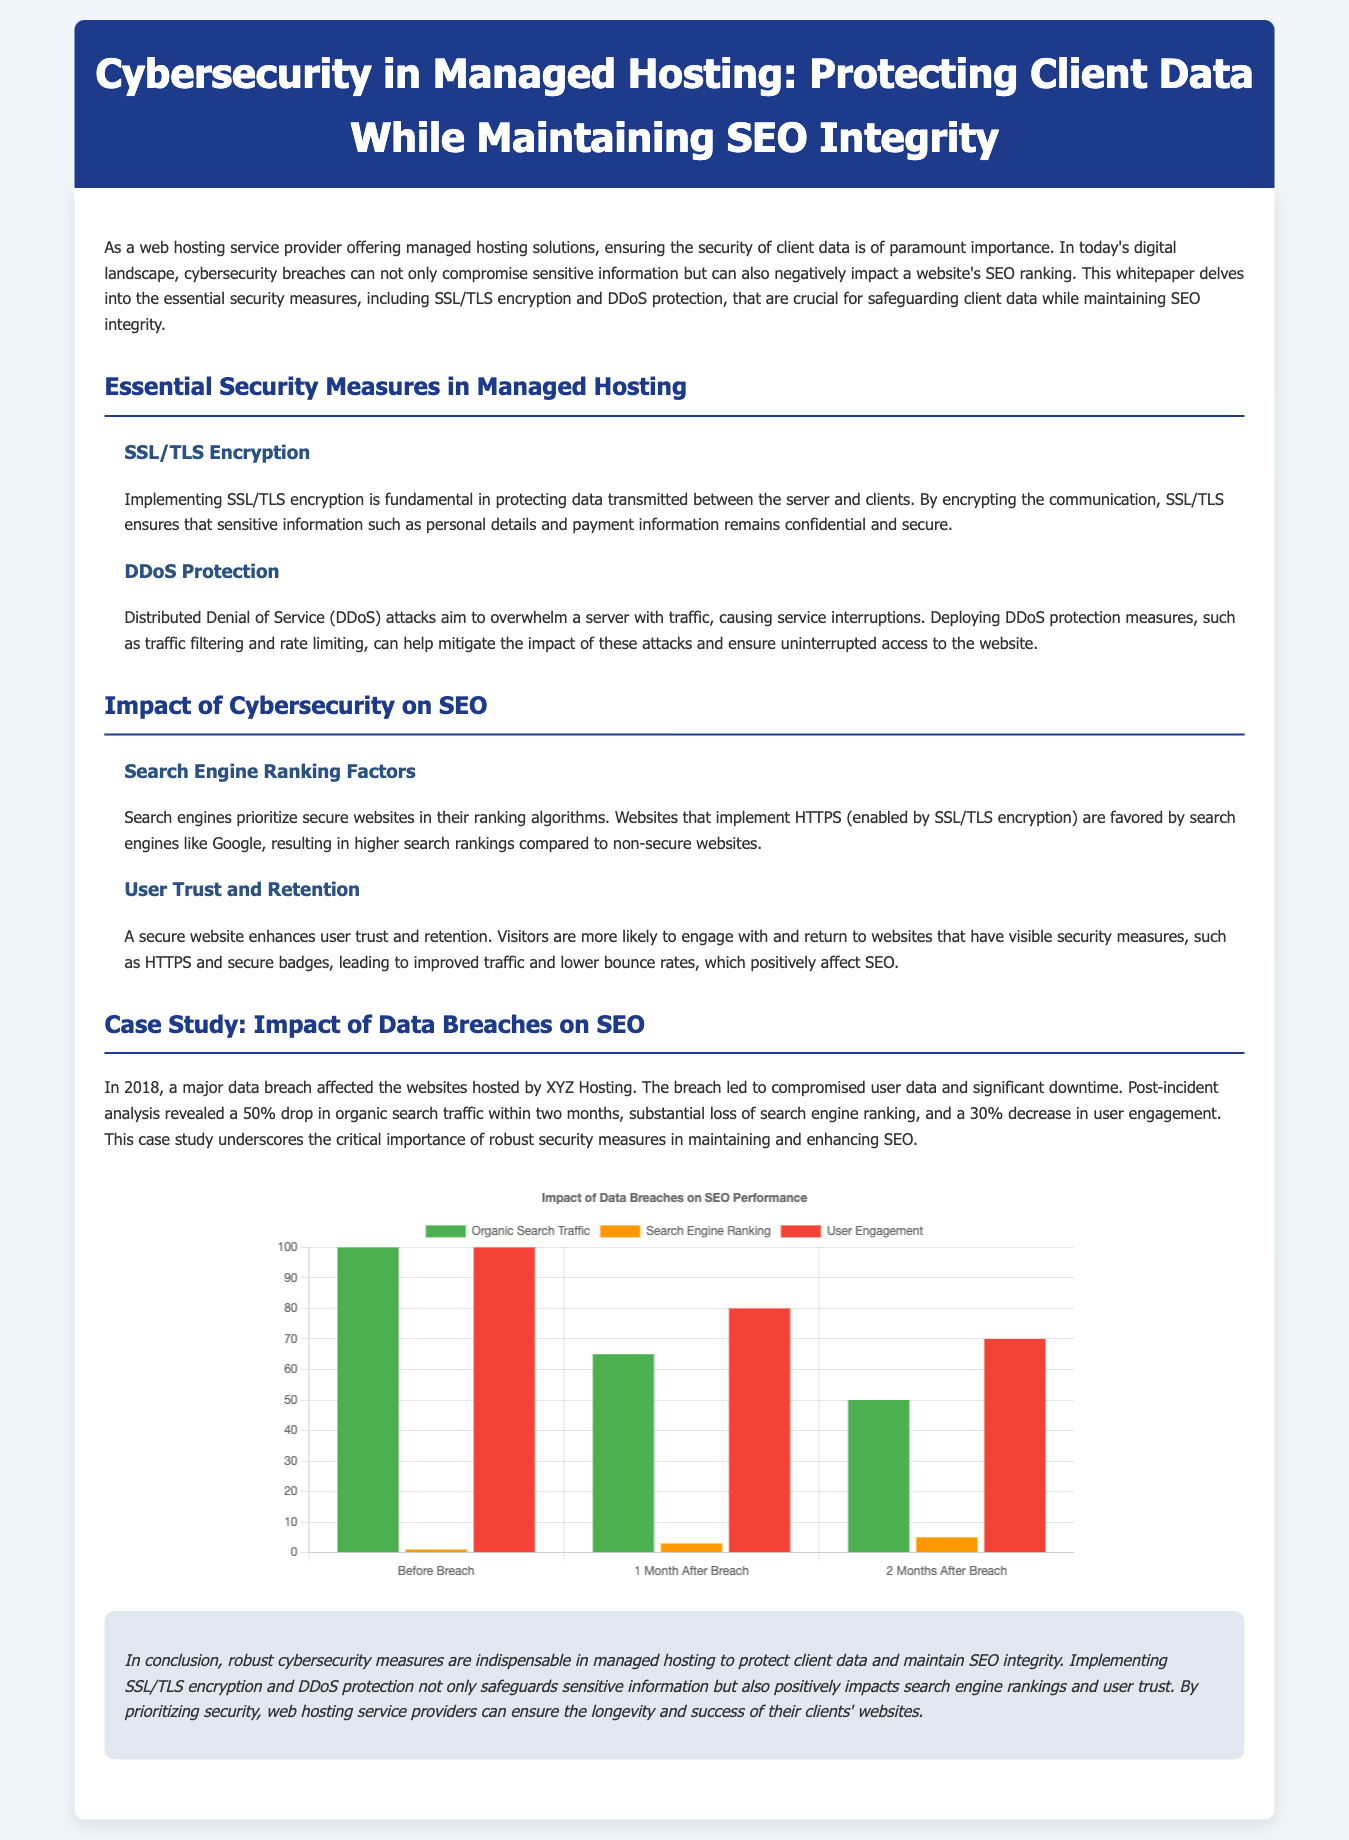what does SSL stand for? The document mentions SSL as an essential part of cybersecurity measures, specifically referring to the importance of encryption.
Answer: Secure Sockets Layer what was the organic search traffic two months after the breach? The rendered document includes data indicating the organic search traffic post-breach.
Answer: 50 how many security measures are highlighted in the document? By examining the sections, we can identify that two specific security measures are emphasized in detail.
Answer: 2 what is the impact on user engagement one month after the data breach? The case study outlines the percentage drop in user engagement within a specified timeframe post-breach.
Answer: 80 what should web hosting service providers prioritize according to the conclusion? The conclusion outlines a clear directive at the end of the document regarding what is essential for service providers.
Answer: security measures what color represents organic search traffic in the chart? The visual data uses specific colors to represent various metrics regarding search performance in the chart.
Answer: green how did the search engine ranking change two months after the breach? The document provides a specific timeline measurement showing the ranking changes after the incident.
Answer: 5 what key benefit does HTTPS provide in terms of SEO? The section explains one major advantage that HTTPS offers, directly linking it to search engine ranking factors.
Answer: higher search rankings what year did the case study data breach occur? The document clearly states the year when the significant data breach happened.
Answer: 2018 